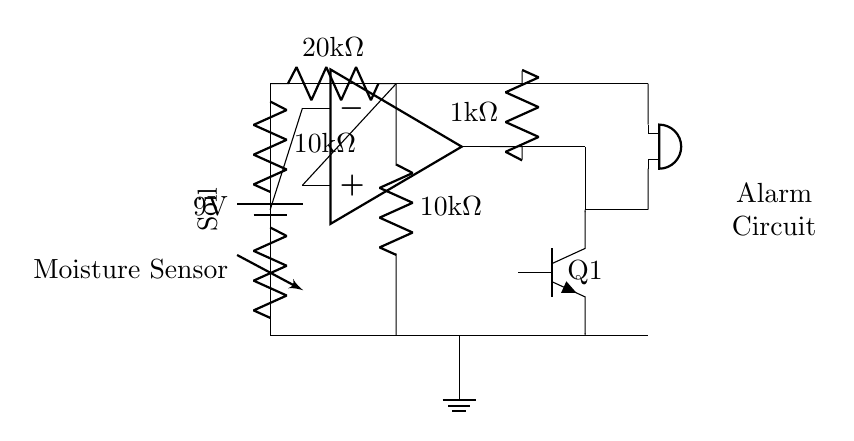What type of sensor is used in this circuit? The circuit uses a moisture sensor, indicated by the labeled component in the schematic.
Answer: moisture sensor What is the power supply voltage? The power supply in the circuit is a battery marked with a voltage of nine volts, shown at the top of the diagram.
Answer: 9 volts How many resistors are present in the circuit? There are three resistors visible in the circuit: a 10k ohm resistor, a 20k ohm resistor, and another 10k ohm resistor, all annotated on the diagram.
Answer: 3 resistors What type of transistor is used in this circuit? The circuit uses a NPN transistor, labeled as Q1 in the schematic, which is specifically depicted in the diagram.
Answer: NPN What triggers the alarm in this moisture sensing circuit? The alarm is triggered when the output of the comparator, which compares the voltage from the moisture sensor to the reference voltage, goes high enough to activate the transistor, thus allowing current to flow to the buzzer.
Answer: comparator output What is the reference voltage determined by in this circuit? The reference voltage is set by the voltage divider formed by the two resistors of 20k ohm and 10k ohm, allowing a specific voltage value for comparison.
Answer: voltage divider 